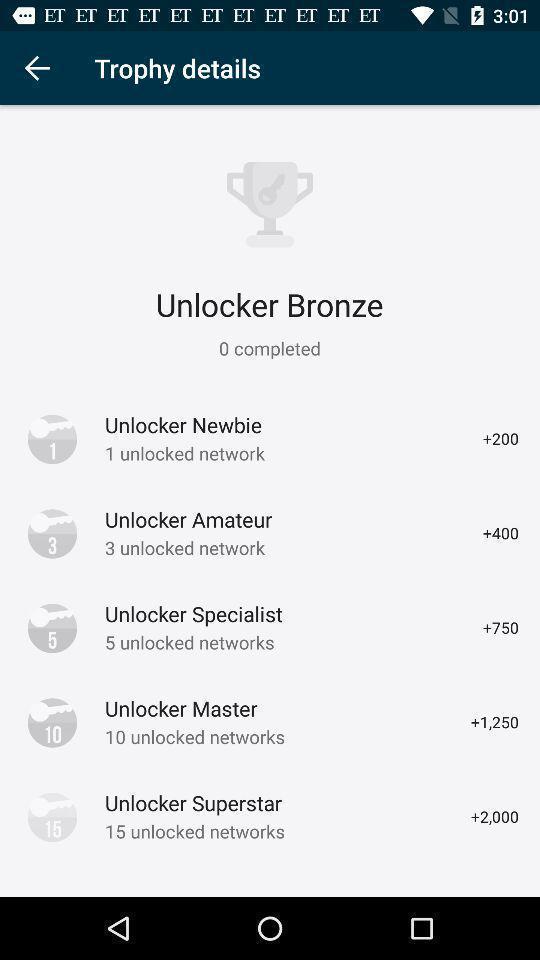Tell me about the visual elements in this screen capture. Window displaying details about trophy. 